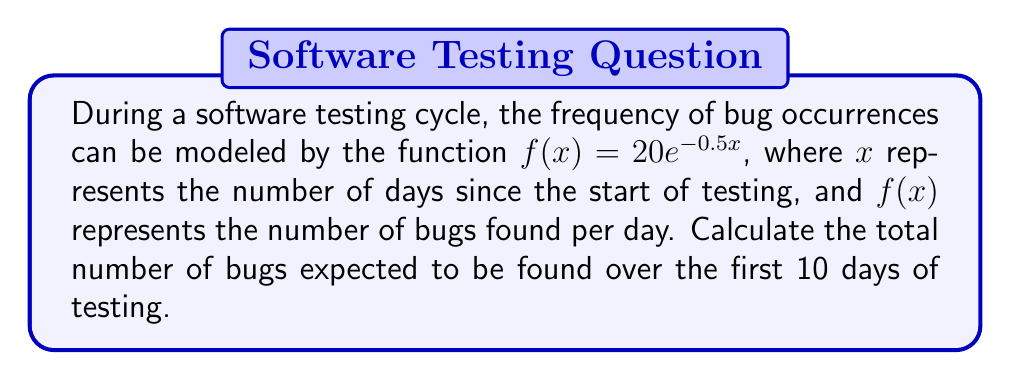What is the answer to this math problem? To solve this problem, we need to calculate the area under the curve of $f(x) = 20e^{-0.5x}$ from $x = 0$ to $x = 10$. This can be done using definite integration.

1. Set up the definite integral:
   $$\int_0^{10} 20e^{-0.5x} dx$$

2. To integrate $e^{-0.5x}$, we use the rule $\int e^{ax} dx = \frac{1}{a}e^{ax} + C$:
   $$20 \int_0^{10} e^{-0.5x} dx = 20 \cdot \left[-\frac{1}{0.5}e^{-0.5x}\right]_0^{10}$$

3. Evaluate the integral:
   $$= 20 \cdot \left[-2e^{-0.5x}\right]_0^{10}$$
   $$= 20 \cdot \left(-2e^{-5} - (-2e^0)\right)$$
   $$= 20 \cdot \left(-2e^{-5} + 2\right)$$
   $$= 20 \cdot 2 \cdot (1 - e^{-5})$$
   $$= 40 \cdot (1 - e^{-5})$$

4. Calculate the final result:
   $$= 40 \cdot (1 - 0.00673795)$$
   $$= 40 \cdot 0.99326205$$
   $$= 39.73048200$$

Therefore, the total number of bugs expected to be found over the first 10 days of testing is approximately 39.73.
Answer: 39.73 bugs 